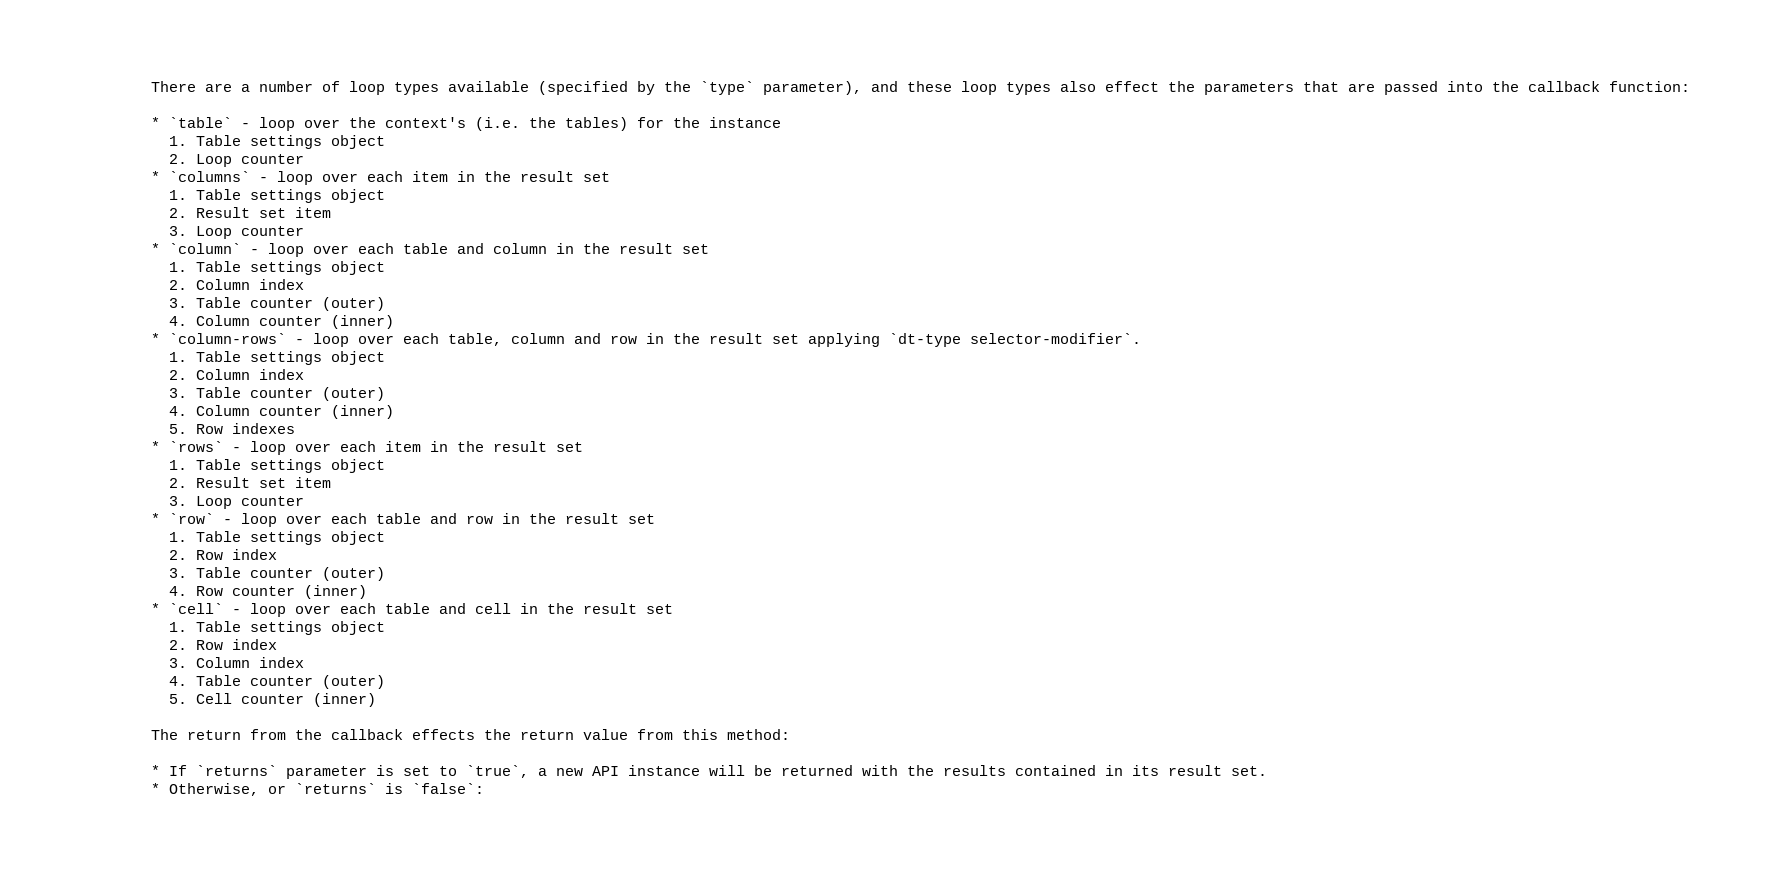<code> <loc_0><loc_0><loc_500><loc_500><_XML_>
		There are a number of loop types available (specified by the `type` parameter), and these loop types also effect the parameters that are passed into the callback function:

		* `table` - loop over the context's (i.e. the tables) for the instance
		  1. Table settings object
		  2. Loop counter
		* `columns` - loop over each item in the result set
		  1. Table settings object
		  2. Result set item
		  3. Loop counter
		* `column` - loop over each table and column in the result set
		  1. Table settings object
		  2. Column index
		  3. Table counter (outer)
		  4. Column counter (inner)
		* `column-rows` - loop over each table, column and row in the result set applying `dt-type selector-modifier`.
		  1. Table settings object
		  2. Column index
		  3. Table counter (outer)
		  4. Column counter (inner)
		  5. Row indexes
		* `rows` - loop over each item in the result set
		  1. Table settings object
		  2. Result set item
		  3. Loop counter
		* `row` - loop over each table and row in the result set
		  1. Table settings object
		  2. Row index
		  3. Table counter (outer)
		  4. Row counter (inner)
		* `cell` - loop over each table and cell in the result set
		  1. Table settings object
		  2. Row index
		  3. Column index
		  4. Table counter (outer)
		  5. Cell counter (inner)

		The return from the callback effects the return value from this method:

		* If `returns` parameter is set to `true`, a new API instance will be returned with the results contained in its result set.
		* Otherwise, or `returns` is `false`:</code> 